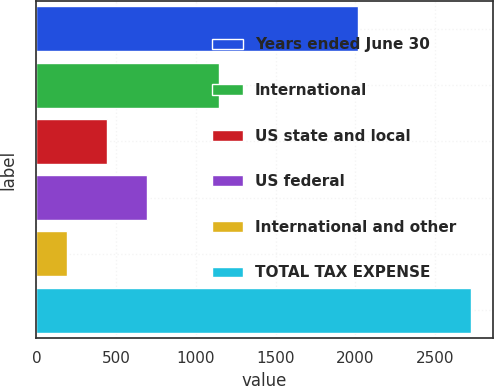Convert chart to OTSL. <chart><loc_0><loc_0><loc_500><loc_500><bar_chart><fcel>Years ended June 30<fcel>International<fcel>US state and local<fcel>US federal<fcel>International and other<fcel>TOTAL TAX EXPENSE<nl><fcel>2015<fcel>1142<fcel>442.6<fcel>696.2<fcel>189<fcel>2725<nl></chart> 